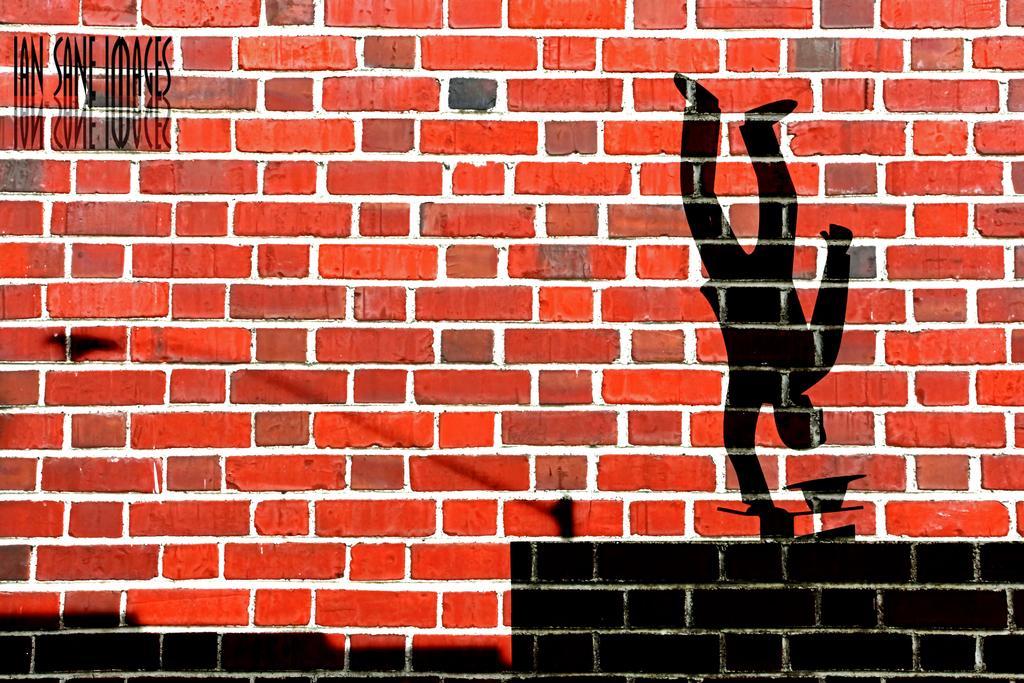Describe this image in one or two sentences. In this picture we can see the brick wall. On the right we can see the painting of a person who is doing stunt. At the top left corner we can see quotation. 